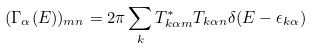<formula> <loc_0><loc_0><loc_500><loc_500>( \Gamma _ { \alpha } ( E ) ) _ { m n } = 2 \pi \sum _ { k } T ^ { * } _ { k \alpha m } T _ { k \alpha n } \delta ( E - \epsilon _ { k \alpha } )</formula> 